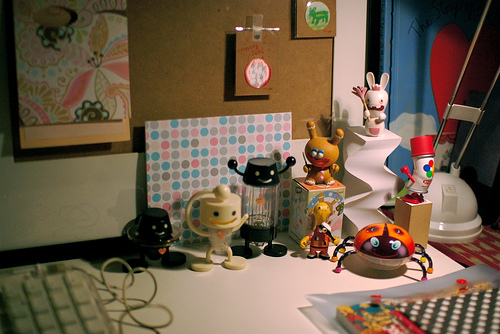<image>
Is there a keyboard in front of the wall? Yes. The keyboard is positioned in front of the wall, appearing closer to the camera viewpoint. 